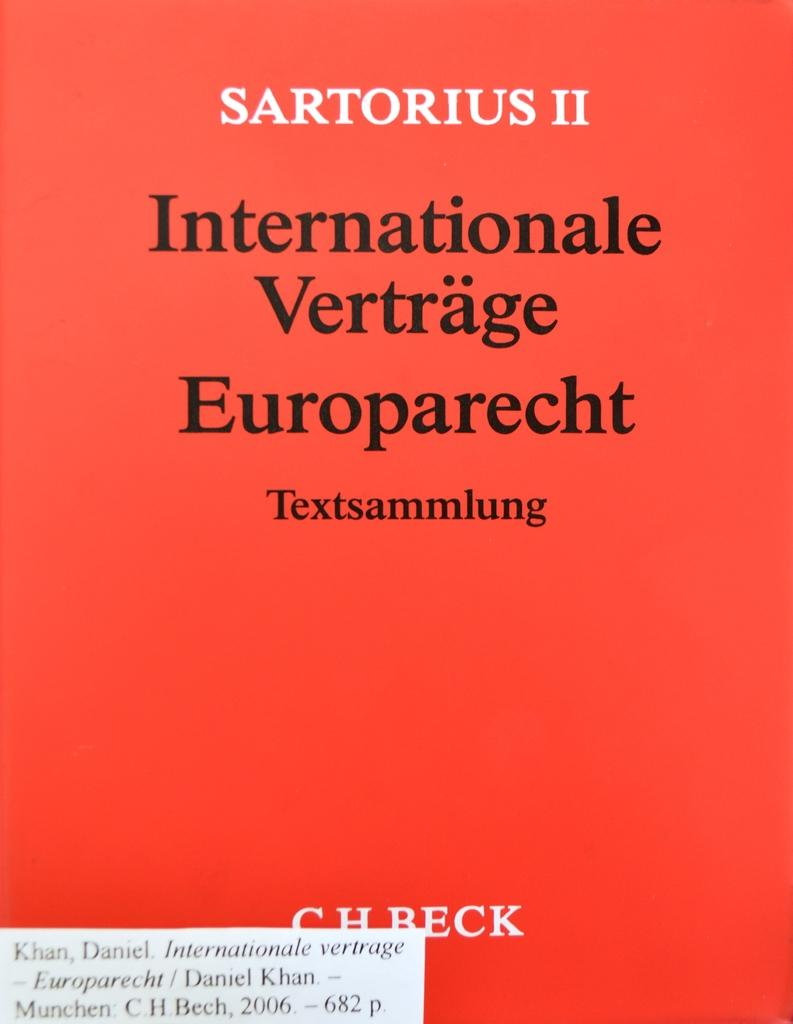Provide a one-sentence caption for the provided image. a book with the name sartorious on it. 